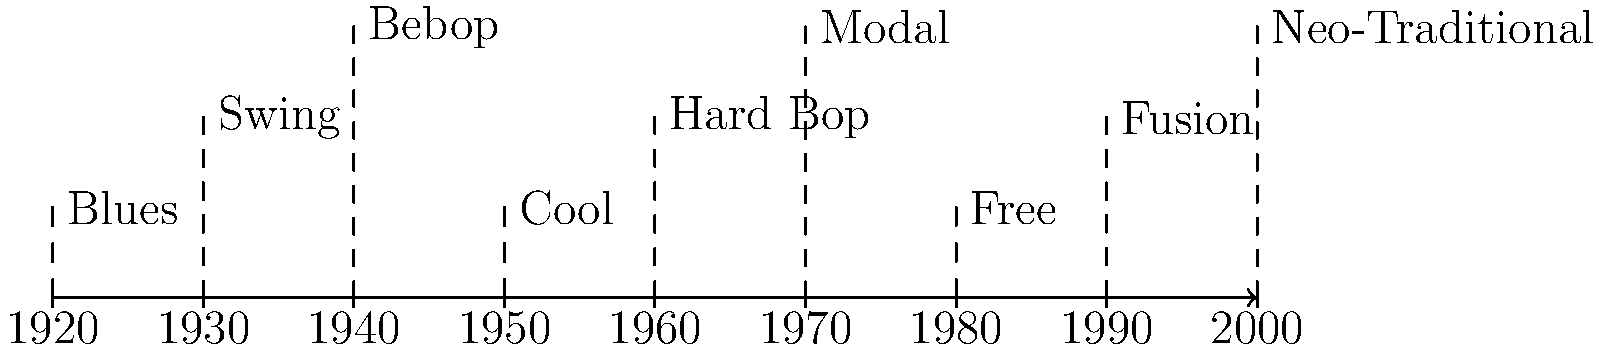Based on the timeline of female jazz vocal styles, which style emerged in the 1940s and was characterized by complex harmonies, fast tempos, and intricate improvisation? To answer this question, we need to analyze the timeline of jazz vocal styles:

1. The timeline spans from the 1920s to the 2000s.
2. Each decade introduces a new vocal style.
3. For the 1940s, we see the emergence of Bebop.
4. Bebop is known for its:
   a) Complex harmonies
   b) Fast tempos
   c) Intricate improvisation

5. These characteristics align with the description in the question.
6. Other styles like Swing (1930s) or Cool (1950s) don't match the time period or the described characteristics.

Therefore, the style that emerged in the 1940s with complex harmonies, fast tempos, and intricate improvisation is Bebop.
Answer: Bebop 